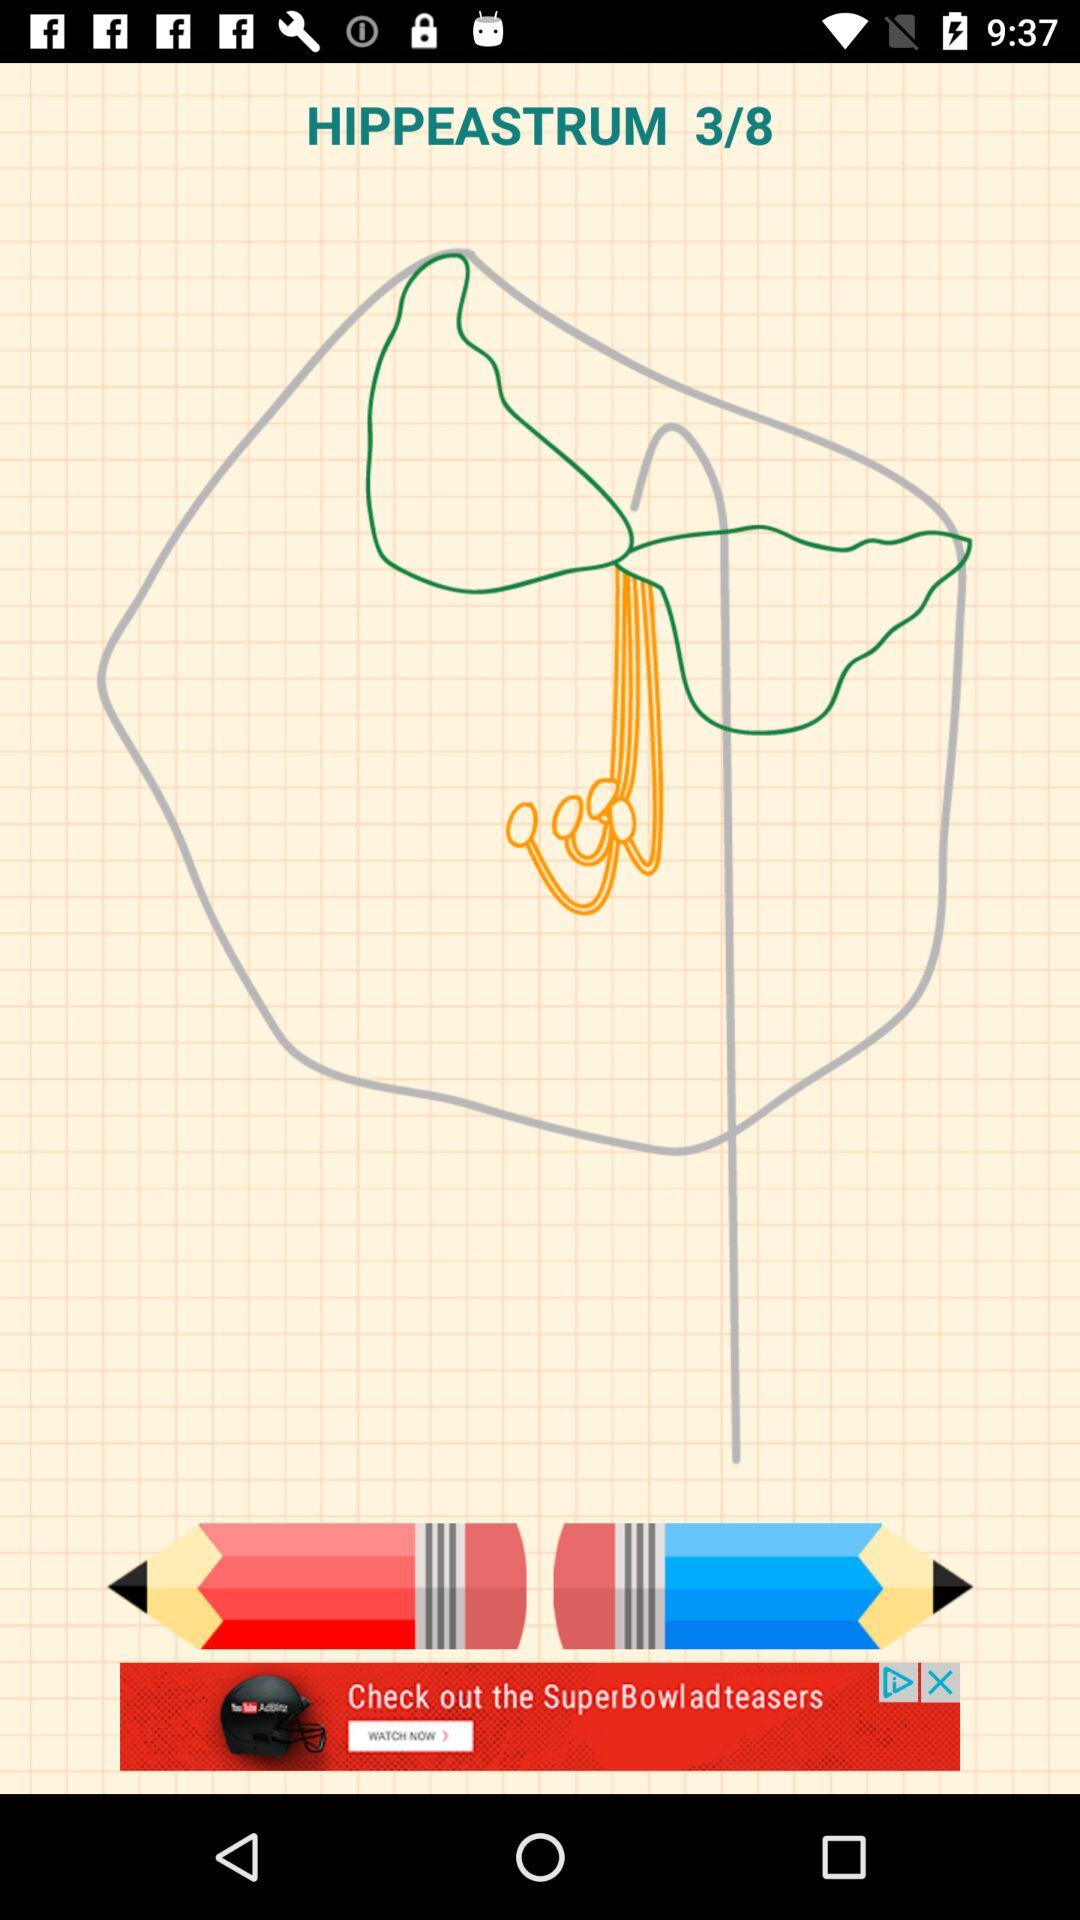What is the name of the image? The name of the image is "HIPPEASTRUM". 